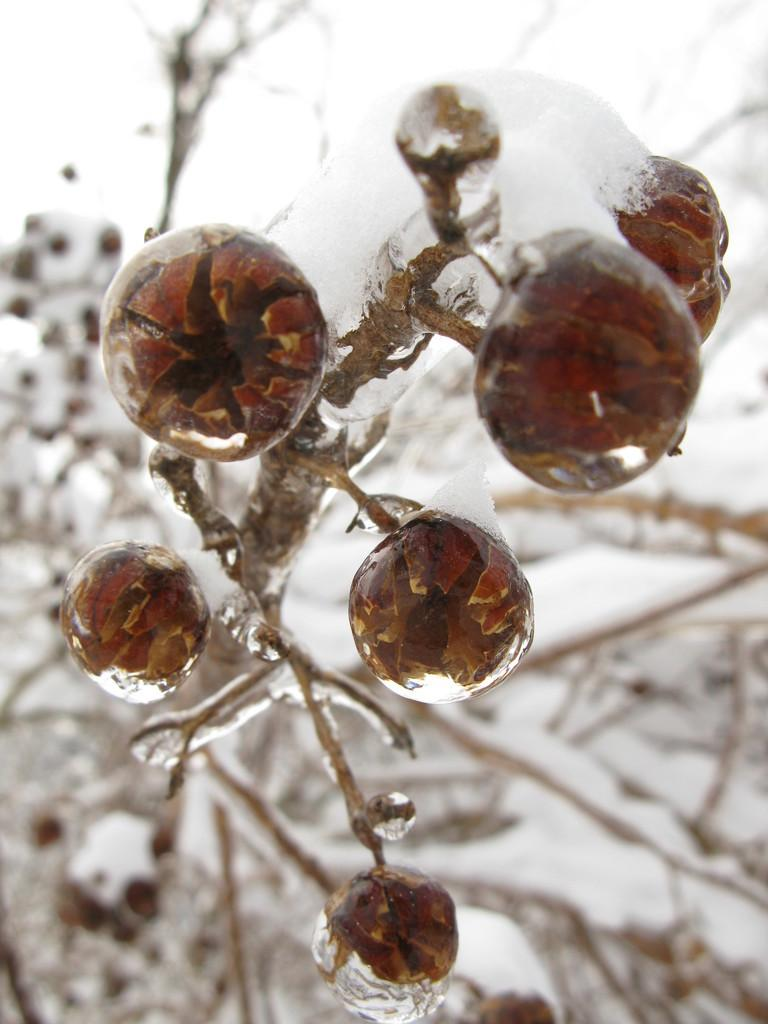What type of plant can be seen in the image? There is a plant with fruits in the image. What is the background of the image like? There is snow visible in the background of the image. How many girls are standing next to the plant in the image? There are no girls present in the image; it only features a plant with fruits and a snowy background. 